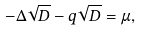Convert formula to latex. <formula><loc_0><loc_0><loc_500><loc_500>- \Delta \sqrt { D } - q \sqrt { D } = \mu ,</formula> 